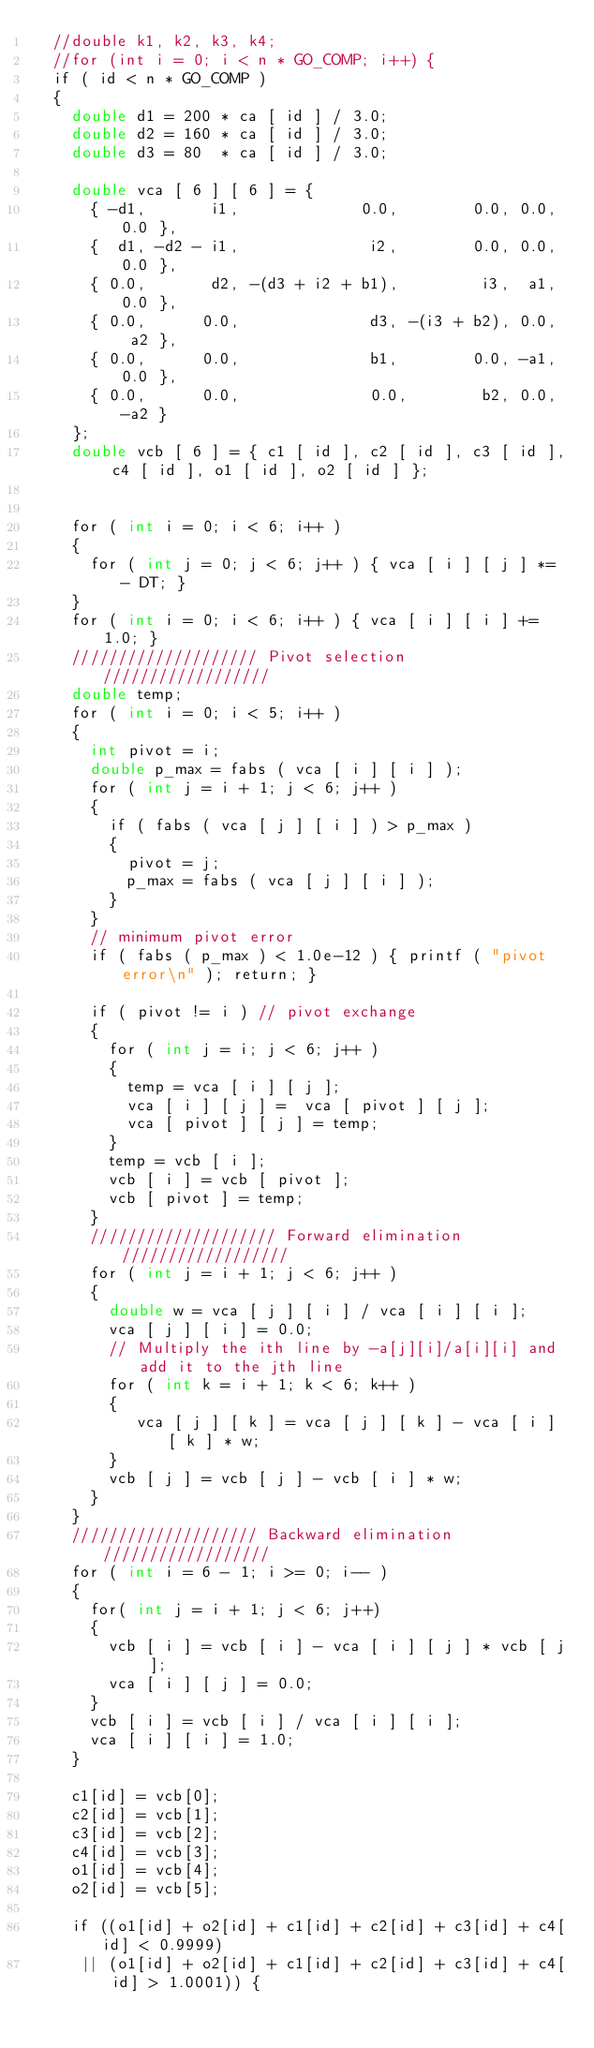Convert code to text. <code><loc_0><loc_0><loc_500><loc_500><_Cuda_>  //double k1, k2, k3, k4;
  //for (int i = 0; i < n * GO_COMP; i++) {
  if ( id < n * GO_COMP )
  {			
    double d1 = 200 * ca [ id ] / 3.0;
    double d2 = 160 * ca [ id ] / 3.0;
    double d3 = 80  * ca [ id ] / 3.0;
  
    double vca [ 6 ] [ 6 ] = {
      { -d1,       i1,             0.0,        0.0, 0.0, 0.0 },
      {  d1, -d2 - i1,              i2,        0.0, 0.0, 0.0 },
      { 0.0,       d2, -(d3 + i2 + b1),         i3,  a1, 0.0 },
      { 0.0,      0.0,              d3, -(i3 + b2), 0.0,  a2 },
      { 0.0,      0.0,              b1,        0.0, -a1, 0.0 },
      { 0.0,      0.0,              0.0,        b2, 0.0, -a2 }
    };
    double vcb [ 6 ] = { c1 [ id ], c2 [ id ], c3 [ id ], c4 [ id ], o1 [ id ], o2 [ id ] };
   
      
    for ( int i = 0; i < 6; i++ )
    { 
      for ( int j = 0; j < 6; j++ ) { vca [ i ] [ j ] *= - DT; }
    }
    for ( int i = 0; i < 6; i++ ) { vca [ i ] [ i ] += 1.0; }
    //////////////////// Pivot selection //////////////////
    double temp;
    for ( int i = 0; i < 5; i++ ) 
    {
      int pivot = i;
      double p_max = fabs ( vca [ i ] [ i ] );
      for ( int j = i + 1; j < 6; j++ )
      {
        if ( fabs ( vca [ j ] [ i ] ) > p_max )
        {
          pivot = j;
          p_max = fabs ( vca [ j ] [ i ] );
        }
      }
      // minimum pivot error
      if ( fabs ( p_max ) < 1.0e-12 ) { printf ( "pivot error\n" ); return; }      
  
      if ( pivot != i ) // pivot exchange
      {
        for ( int j = i; j < 6; j++ )
        {
          temp = vca [ i ] [ j ];
          vca [ i ] [ j ] =  vca [ pivot ] [ j ];
          vca [ pivot ] [ j ] = temp;
        }
        temp = vcb [ i ];
        vcb [ i ] = vcb [ pivot ];
        vcb [ pivot ] = temp;
      }
      //////////////////// Forward elimination //////////////////
      for ( int j = i + 1; j < 6; j++ ) 
      {
        double w = vca [ j ] [ i ] / vca [ i ] [ i ];
        vca [ j ] [ i ] = 0.0;
        // Multiply the ith line by -a[j][i]/a[i][i] and add it to the jth line
        for ( int k = i + 1; k < 6; k++ ) 
        {
           vca [ j ] [ k ] = vca [ j ] [ k ] - vca [ i ] [ k ] * w;
        }
        vcb [ j ] = vcb [ j ] - vcb [ i ] * w;
      }
    }
    //////////////////// Backward elimination //////////////////   
    for ( int i = 6 - 1; i >= 0; i-- )
    {
      for( int j = i + 1; j < 6; j++)
      {
        vcb [ i ] = vcb [ i ] - vca [ i ] [ j ] * vcb [ j ];
        vca [ i ] [ j ] = 0.0;
      }
      vcb [ i ] = vcb [ i ] / vca [ i ] [ i ];
      vca [ i ] [ i ] = 1.0;
    }       
      
    c1[id] = vcb[0];
    c2[id] = vcb[1];
    c3[id] = vcb[2];
    c4[id] = vcb[3];
    o1[id] = vcb[4];
    o2[id] = vcb[5];
  
    if ((o1[id] + o2[id] + c1[id] + c2[id] + c3[id] + c4[id] < 0.9999)
     || (o1[id] + o2[id] + c1[id] + c2[id] + c3[id] + c4[id] > 1.0001)) {</code> 